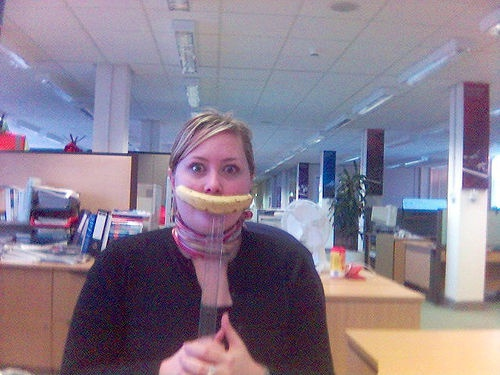Describe the objects in this image and their specific colors. I can see people in purple, black, navy, and violet tones, potted plant in purple, gray, blue, and navy tones, banana in purple, gray, tan, and lightgray tones, book in purple, darkgray, and gray tones, and book in purple, navy, and darkgray tones in this image. 